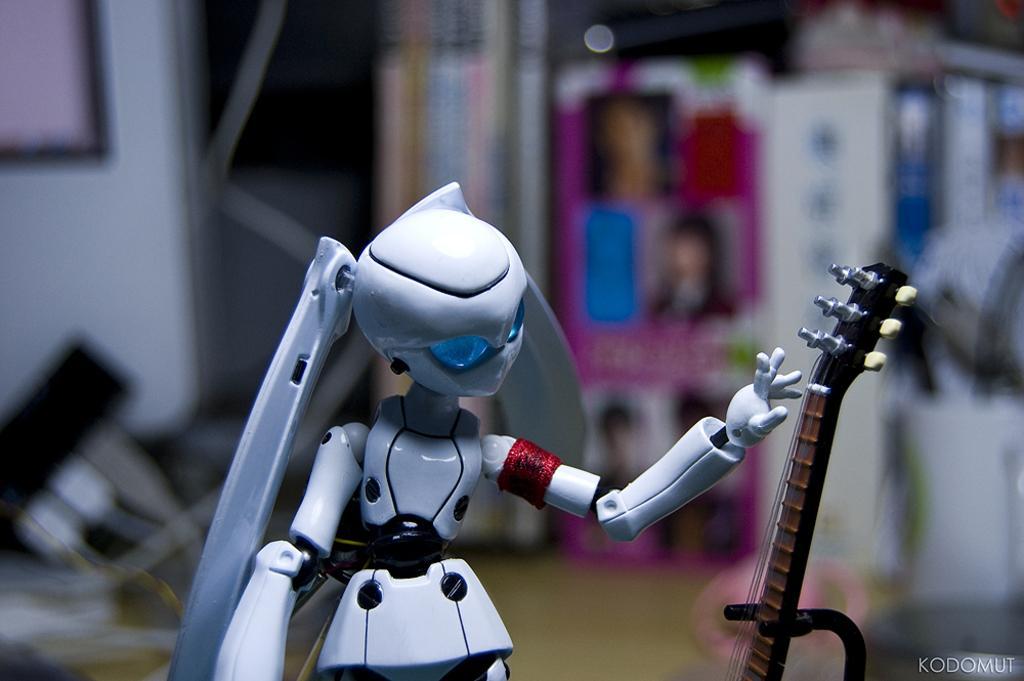In one or two sentences, can you explain what this image depicts? This is a picture of a toy of a girl and stand of the musical instrument kept on the right side and there is a some text written on the right corner 